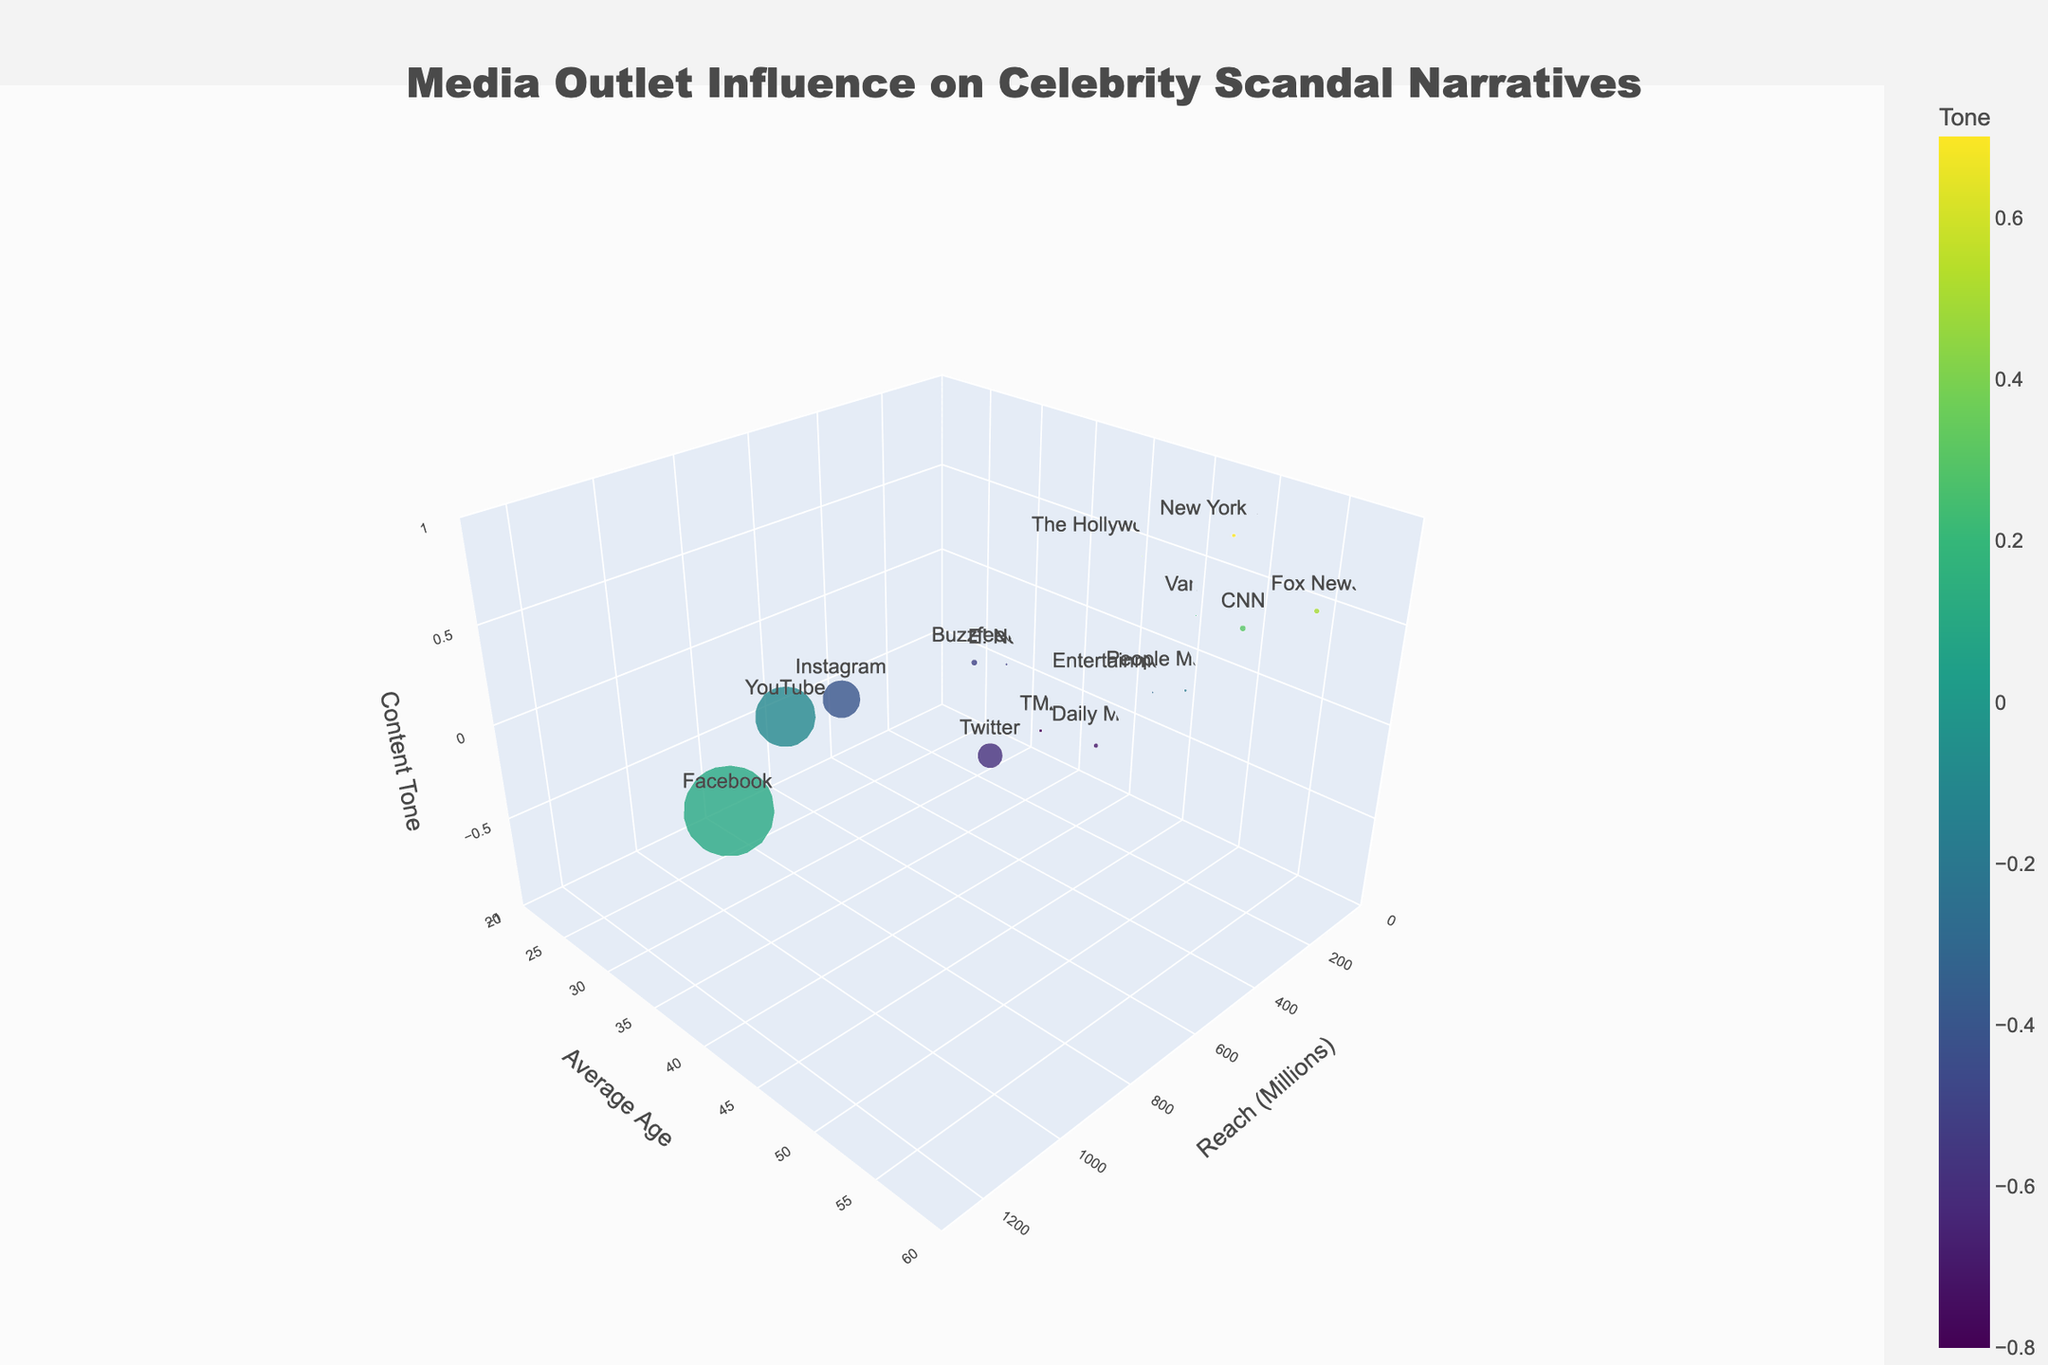What is the highest reach value among the media outlets? The "Reach (Millions)" axis indicates the coverage of each platform. By looking at the figure, the platform with the highest reach is seen at the extreme right end of the reach axis. Instagram has the highest reach of 1200 million.
Answer: Instagram, 1200 million Which media outlet targets the youngest average age demographic? Examine the "Avg Age" axis to find the platform with the lowest value. Instagram has an average age of 25, which is the lowest among all media outlets shown.
Answer: Instagram, 25 How does the tone of TMZ compare to that of the New York Times? Compare the z-axis (Tone) positions of TMZ and the New York Times. TMZ is positioned at -0.8 while the New York Times is at 0.7, indicating TMZ has a much more negative tone compared to the positive tone of the New York Times.
Answer: TMZ has a more negative tone, New York Times has a positive tone Which platforms have a negative content tone but reach more than 100 million? Look at the points in the negative range on the "Tone" axis and check their positions on the "Reach (Millions)" axis. Twitter and Instagram have negative tones (-0.6 and -0.4 respectively) and reach 330 million and 500 million respectively.
Answer: Twitter, Instagram What is the average reach of platforms with a positive content tone? Find platforms with a Tone value greater than 0 on the z-axis, then sum their Reach (Millions) values and divide by the number of such platforms: CNN (80), Fox News (70), New York Times (50), Variety (20), The Hollywood Reporter (15). The total reach is 80 + 70 + 50 + 20 + 15 = 235. There are 5 such platforms. Average reach = 235/5 = 47.
Answer: 47 million Which media outlets cluster around an average age of 40-45 years? Look for points around the 40-45 range on the "Avg Age" axis and identify the corresponding platforms. People Magazine, New York Times, Variety, and The Hollywood Reporter fall in this range.
Answer: People Magazine, New York Times, Variety, The Hollywood Reporter What is the difference in content tone between Daily Mail and Buzzfeed? Check the z-axis (Tone) value for Daily Mail and Buzzfeed. Daily Mail has a tone of -0.7 while Buzzfeed has -0.5. The difference is -0.7 - (-0.5) = -0.2.
Answer: -0.2 Which platform has a medium reach but a predominantly negative tone? Look for a point in the middle range of the "Reach (Millions)" axis with a negative value on the "Tone" axis. Daily Mail, with a reach of 60 million and a tone of -0.7, fits this description.
Answer: Daily Mail What is the average age of the demographic for platforms with reach below 50 million? Calculate the average age of platforms with reach < 50 million: Entertainment Tonight (42), Variety (45), The Hollywood Reporter (40). The sum of ages = 42 + 45 + 40 = 127, and there are 3 platforms. Average age = 127 / 3 = 42.3.
Answer: 42.3 years 